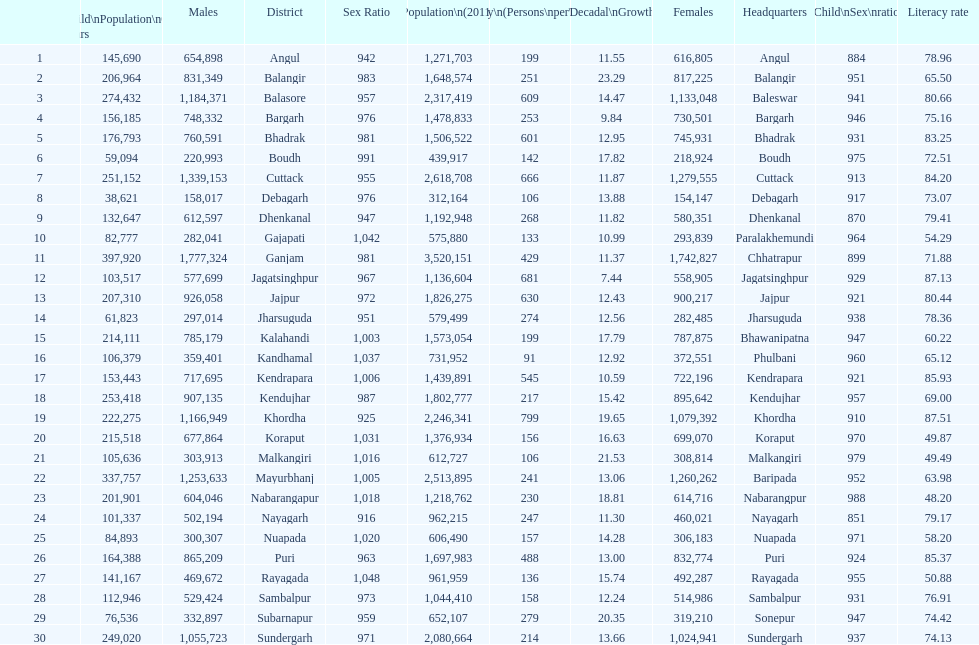What is the difference in child population between koraput and puri? 51,130. 